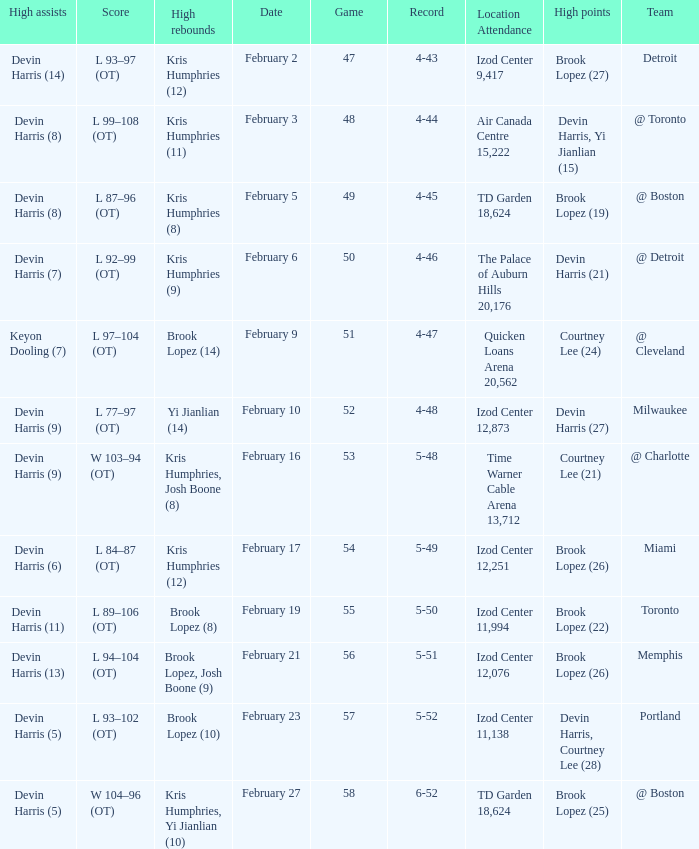When brook lopez (8) achieved his highest number of rebounds, what was the score of that game? L 89–106 (OT). 